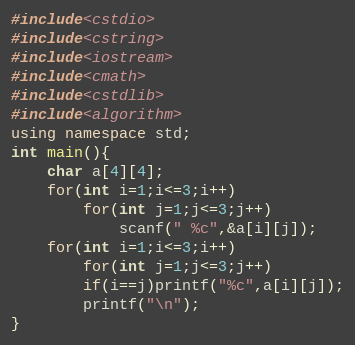<code> <loc_0><loc_0><loc_500><loc_500><_C++_>#include<cstdio>
#include<cstring>
#include<iostream>
#include<cmath>
#include<cstdlib>
#include<algorithm>
using namespace std;
int main(){
	char a[4][4];
	for(int i=1;i<=3;i++)
		for(int j=1;j<=3;j++)
			scanf(" %c",&a[i][j]);
	for(int i=1;i<=3;i++)
		for(int j=1;j<=3;j++)
		if(i==j)printf("%c",a[i][j]);
		printf("\n");
}
</code> 